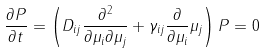Convert formula to latex. <formula><loc_0><loc_0><loc_500><loc_500>\frac { \partial P } { \partial t } = \left ( D _ { i j } \frac { \partial ^ { 2 } } { \partial \mu _ { i } \partial \mu _ { j } } + \gamma _ { i j } \frac { \partial } { \partial \mu _ { i } } \mu _ { j } \right ) P = 0</formula> 